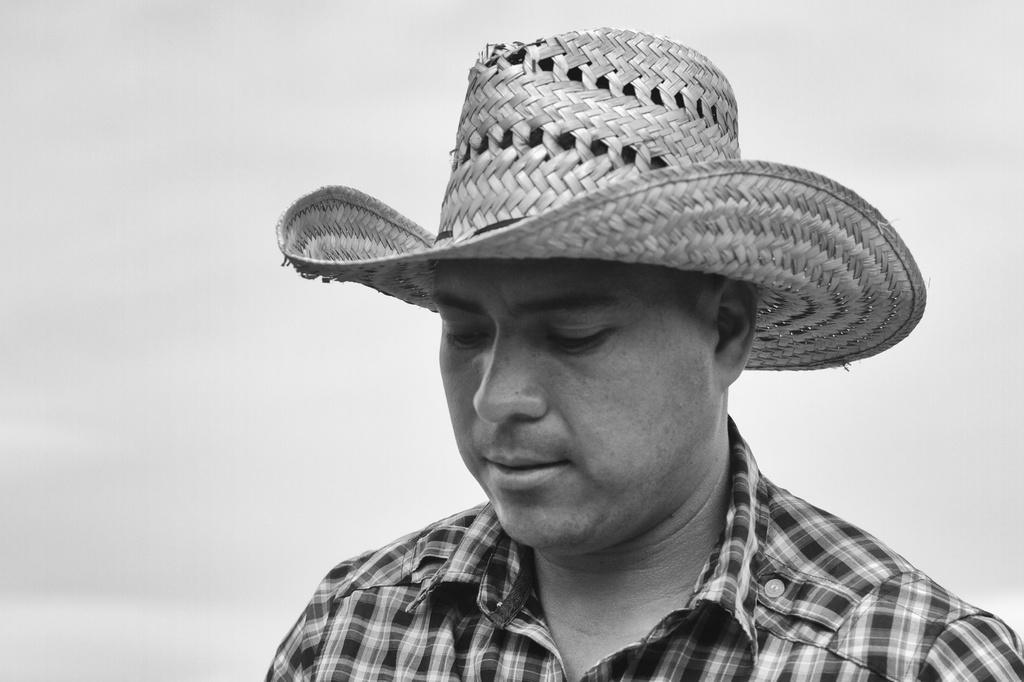Please provide a concise description of this image. In this picture we can see a man wearing checked shirt and hat is looking down. Behind there is a white background. 